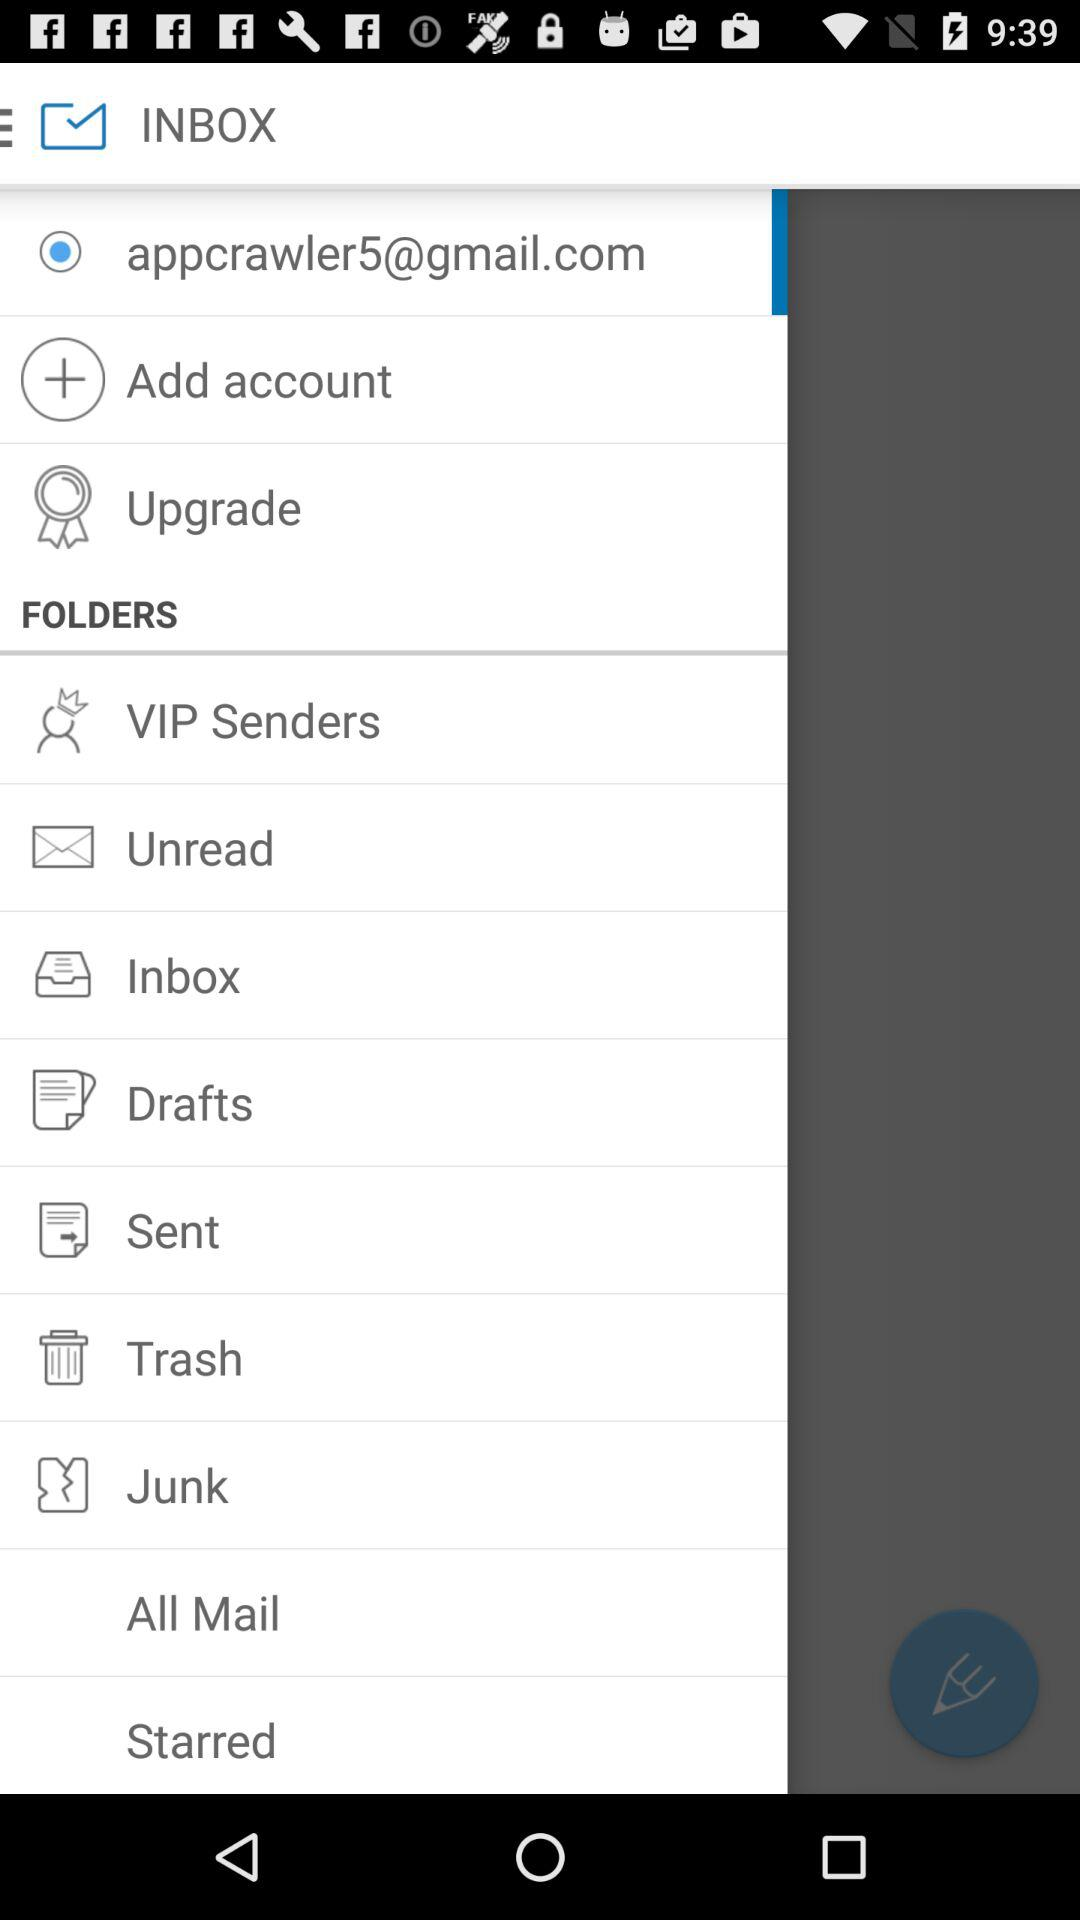What is the email address? The email address is appcrawler5@gmail.com. 